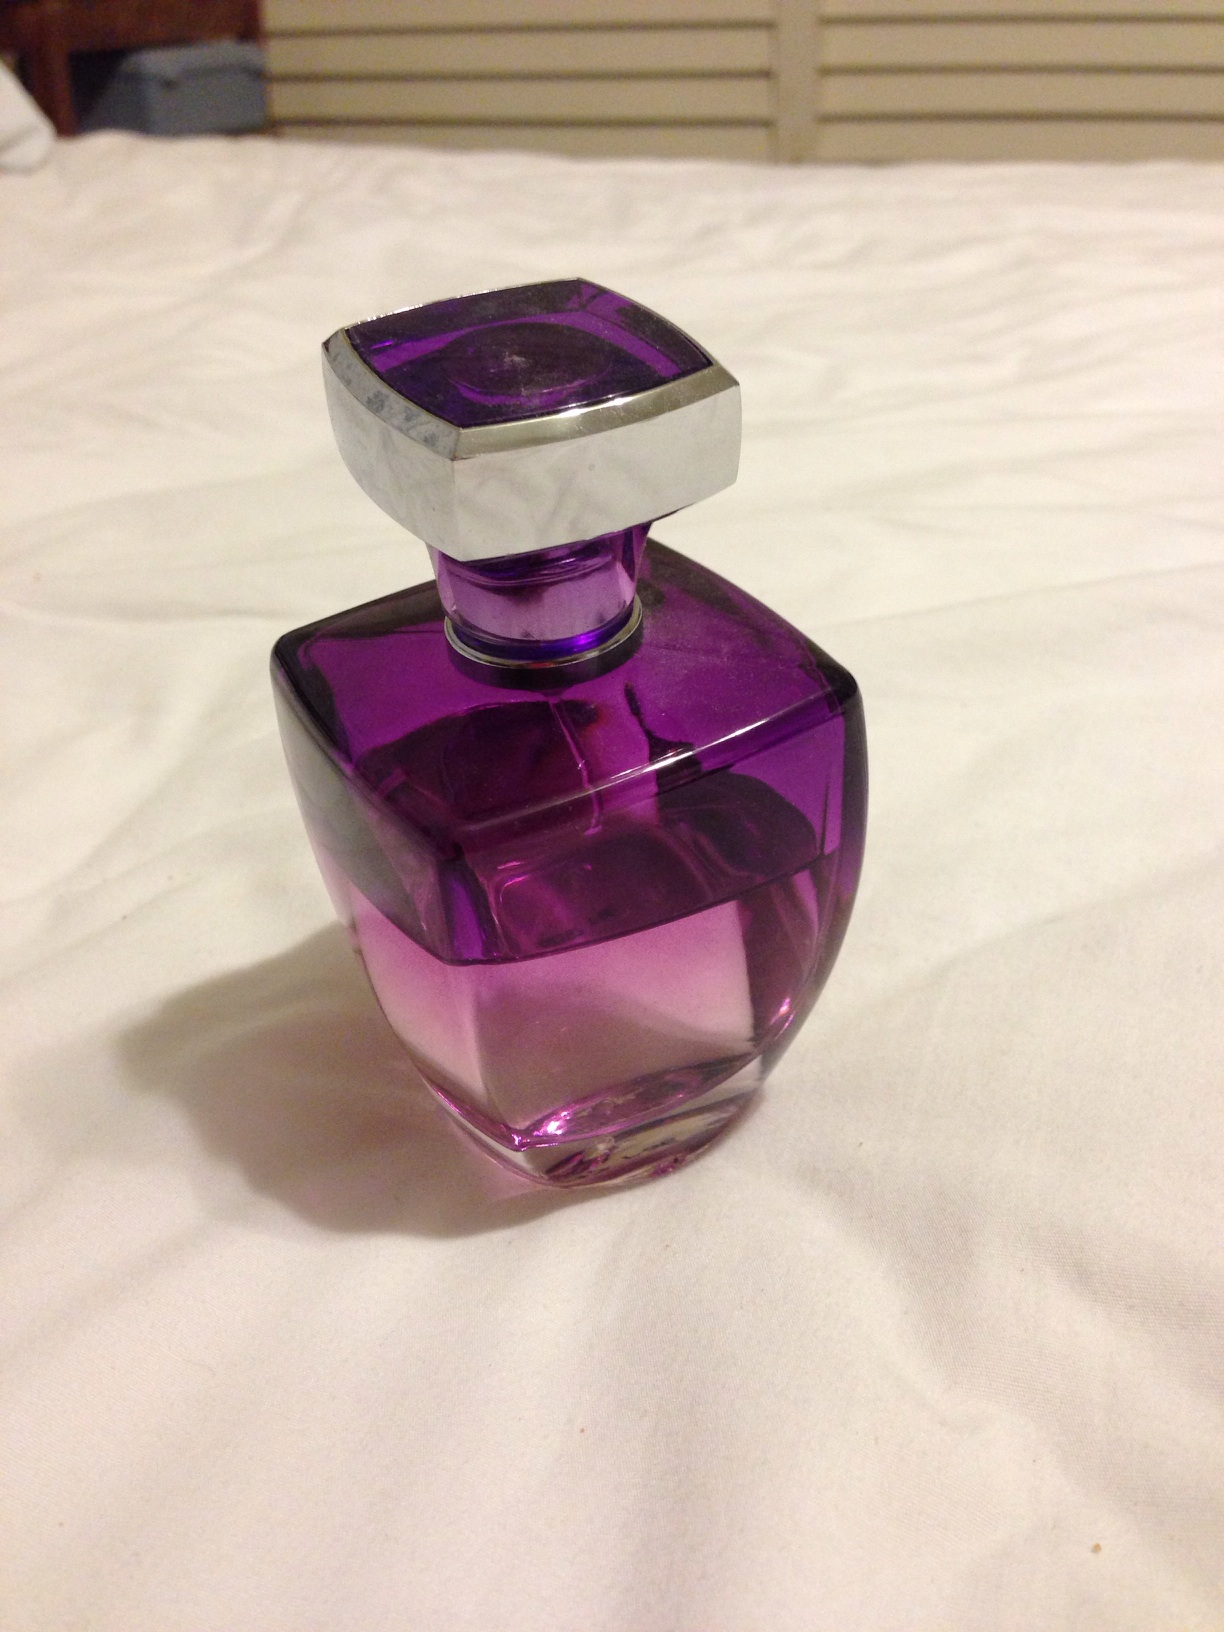Can you tell me more about the design of this perfume bottle? Certainly! The perfume bottle features a bold, purple color, giving it a striking visual appeal. Its cap has a geometric cut, reminiscent of a jewel or crystal, adding a touch of elegance and suggesting the fragrance inside might be just as captivating and refined. 